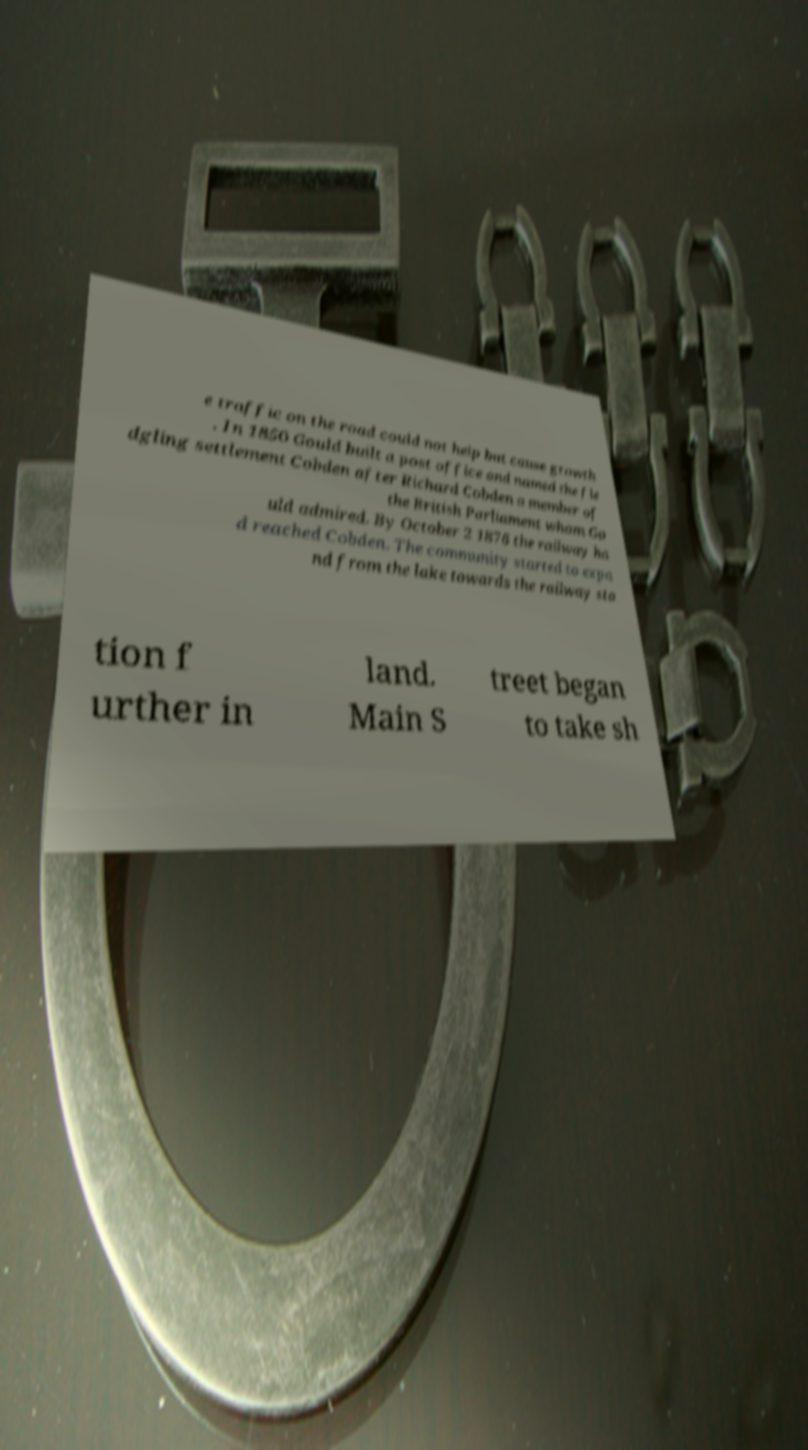What messages or text are displayed in this image? I need them in a readable, typed format. e traffic on the road could not help but cause growth . In 1850 Gould built a post office and named the fle dgling settlement Cobden after Richard Cobden a member of the British Parliament whom Go uld admired. By October 2 1876 the railway ha d reached Cobden. The community started to expa nd from the lake towards the railway sta tion f urther in land. Main S treet began to take sh 